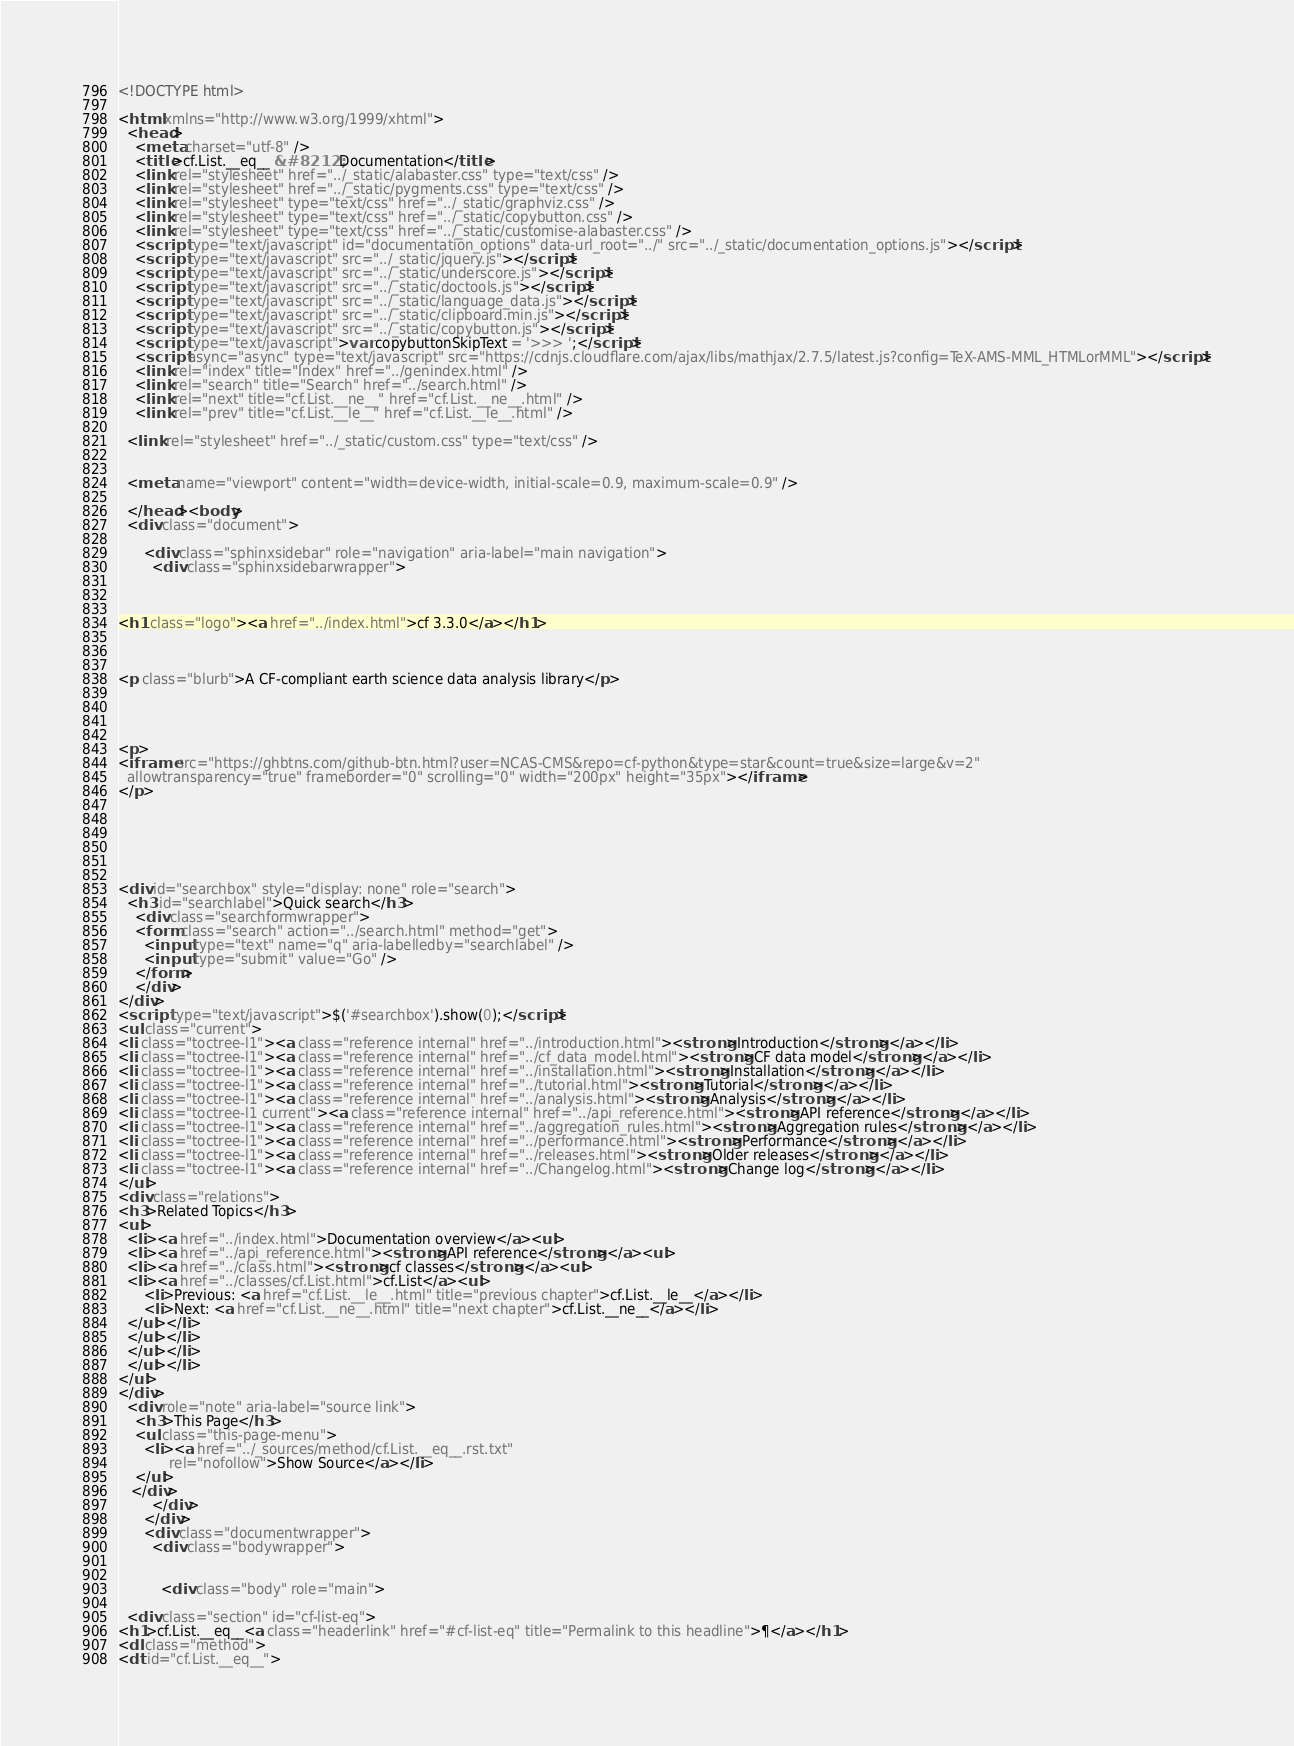Convert code to text. <code><loc_0><loc_0><loc_500><loc_500><_HTML_>
<!DOCTYPE html>

<html xmlns="http://www.w3.org/1999/xhtml">
  <head>
    <meta charset="utf-8" />
    <title>cf.List.__eq__ &#8212; Documentation</title>
    <link rel="stylesheet" href="../_static/alabaster.css" type="text/css" />
    <link rel="stylesheet" href="../_static/pygments.css" type="text/css" />
    <link rel="stylesheet" type="text/css" href="../_static/graphviz.css" />
    <link rel="stylesheet" type="text/css" href="../_static/copybutton.css" />
    <link rel="stylesheet" type="text/css" href="../_static/customise-alabaster.css" />
    <script type="text/javascript" id="documentation_options" data-url_root="../" src="../_static/documentation_options.js"></script>
    <script type="text/javascript" src="../_static/jquery.js"></script>
    <script type="text/javascript" src="../_static/underscore.js"></script>
    <script type="text/javascript" src="../_static/doctools.js"></script>
    <script type="text/javascript" src="../_static/language_data.js"></script>
    <script type="text/javascript" src="../_static/clipboard.min.js"></script>
    <script type="text/javascript" src="../_static/copybutton.js"></script>
    <script type="text/javascript">var copybuttonSkipText = '>>> ';</script>
    <script async="async" type="text/javascript" src="https://cdnjs.cloudflare.com/ajax/libs/mathjax/2.7.5/latest.js?config=TeX-AMS-MML_HTMLorMML"></script>
    <link rel="index" title="Index" href="../genindex.html" />
    <link rel="search" title="Search" href="../search.html" />
    <link rel="next" title="cf.List.__ne__" href="cf.List.__ne__.html" />
    <link rel="prev" title="cf.List.__le__" href="cf.List.__le__.html" />
   
  <link rel="stylesheet" href="../_static/custom.css" type="text/css" />
  
  
  <meta name="viewport" content="width=device-width, initial-scale=0.9, maximum-scale=0.9" />

  </head><body>
  <div class="document">
    
      <div class="sphinxsidebar" role="navigation" aria-label="main navigation">
        <div class="sphinxsidebarwrapper">



<h1 class="logo"><a href="../index.html">cf 3.3.0</a></h1>



<p class="blurb">A CF-compliant earth science data analysis library</p>




<p>
<iframe src="https://ghbtns.com/github-btn.html?user=NCAS-CMS&repo=cf-python&type=star&count=true&size=large&v=2"
  allowtransparency="true" frameborder="0" scrolling="0" width="200px" height="35px"></iframe>
</p>






<div id="searchbox" style="display: none" role="search">
  <h3 id="searchlabel">Quick search</h3>
    <div class="searchformwrapper">
    <form class="search" action="../search.html" method="get">
      <input type="text" name="q" aria-labelledby="searchlabel" />
      <input type="submit" value="Go" />
    </form>
    </div>
</div>
<script type="text/javascript">$('#searchbox').show(0);</script>
<ul class="current">
<li class="toctree-l1"><a class="reference internal" href="../introduction.html"><strong>Introduction</strong></a></li>
<li class="toctree-l1"><a class="reference internal" href="../cf_data_model.html"><strong>CF data model</strong></a></li>
<li class="toctree-l1"><a class="reference internal" href="../installation.html"><strong>Installation</strong></a></li>
<li class="toctree-l1"><a class="reference internal" href="../tutorial.html"><strong>Tutorial</strong></a></li>
<li class="toctree-l1"><a class="reference internal" href="../analysis.html"><strong>Analysis</strong></a></li>
<li class="toctree-l1 current"><a class="reference internal" href="../api_reference.html"><strong>API reference</strong></a></li>
<li class="toctree-l1"><a class="reference internal" href="../aggregation_rules.html"><strong>Aggregation rules</strong></a></li>
<li class="toctree-l1"><a class="reference internal" href="../performance.html"><strong>Performance</strong></a></li>
<li class="toctree-l1"><a class="reference internal" href="../releases.html"><strong>Older releases</strong></a></li>
<li class="toctree-l1"><a class="reference internal" href="../Changelog.html"><strong>Change log</strong></a></li>
</ul>
<div class="relations">
<h3>Related Topics</h3>
<ul>
  <li><a href="../index.html">Documentation overview</a><ul>
  <li><a href="../api_reference.html"><strong>API reference</strong></a><ul>
  <li><a href="../class.html"><strong>cf classes</strong></a><ul>
  <li><a href="../classes/cf.List.html">cf.List</a><ul>
      <li>Previous: <a href="cf.List.__le__.html" title="previous chapter">cf.List.__le__</a></li>
      <li>Next: <a href="cf.List.__ne__.html" title="next chapter">cf.List.__ne__</a></li>
  </ul></li>
  </ul></li>
  </ul></li>
  </ul></li>
</ul>
</div>
  <div role="note" aria-label="source link">
    <h3>This Page</h3>
    <ul class="this-page-menu">
      <li><a href="../_sources/method/cf.List.__eq__.rst.txt"
            rel="nofollow">Show Source</a></li>
    </ul>
   </div>
        </div>
      </div>
      <div class="documentwrapper">
        <div class="bodywrapper">
          

          <div class="body" role="main">
            
  <div class="section" id="cf-list-eq">
<h1>cf.List.__eq__<a class="headerlink" href="#cf-list-eq" title="Permalink to this headline">¶</a></h1>
<dl class="method">
<dt id="cf.List.__eq__"></code> 